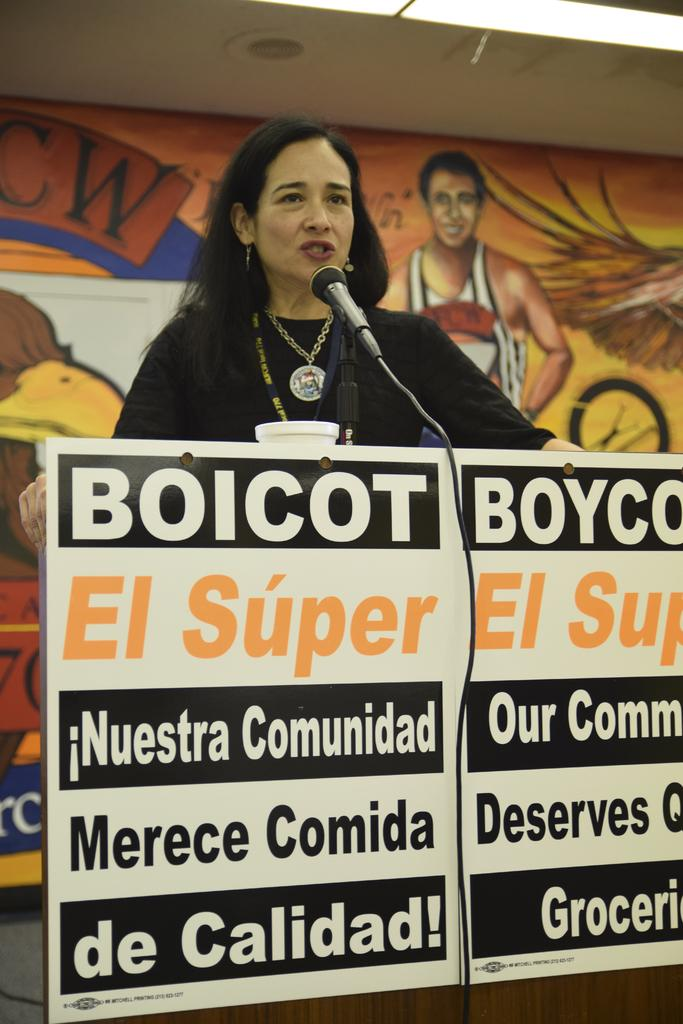What is the person in the image doing? There is a person standing at the table in the image. What object can be seen near the person? There is a microphone (mike) in the image. What can be seen in the background of the image? There is a wall in the background of the image. What is on the wall in the background? There is a painting on the wall in the background. Can you see the person kissing someone in the image? There is no indication of a kiss or another person in the image. Is the person wearing a mask in the image? There is no mention of a mask in the image, and no such object is visible. 